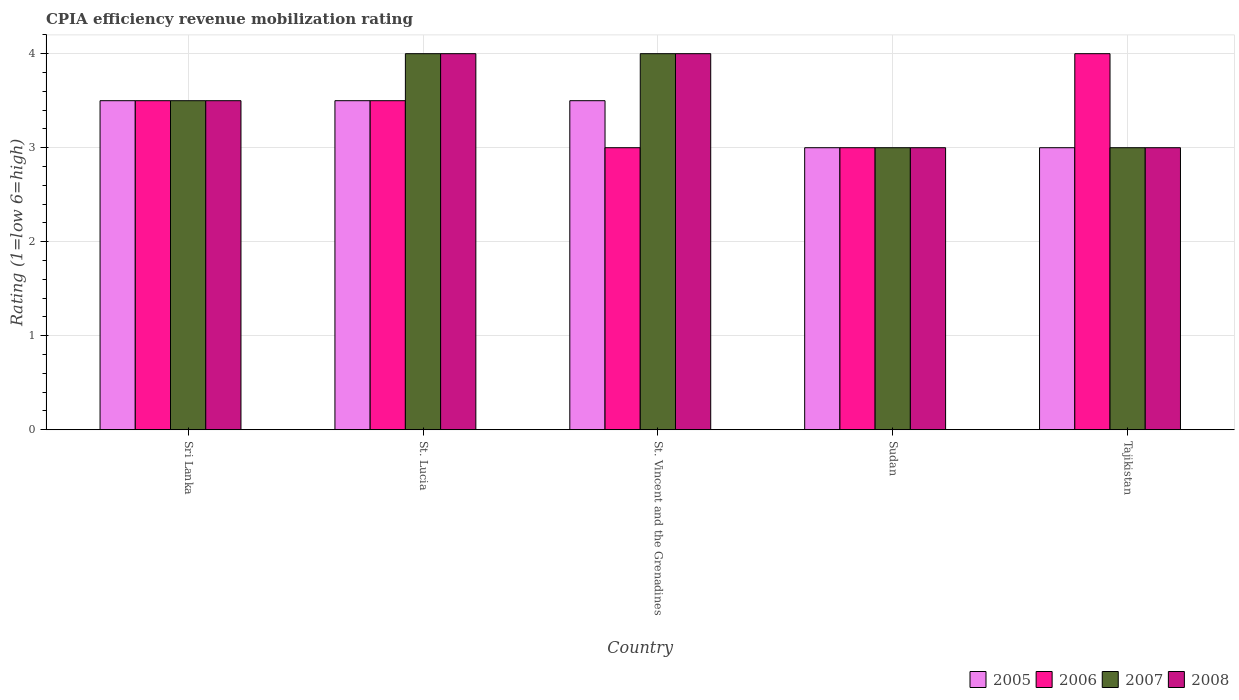How many different coloured bars are there?
Provide a short and direct response. 4. How many groups of bars are there?
Provide a short and direct response. 5. Are the number of bars on each tick of the X-axis equal?
Provide a succinct answer. Yes. How many bars are there on the 1st tick from the left?
Provide a succinct answer. 4. How many bars are there on the 1st tick from the right?
Offer a terse response. 4. What is the label of the 2nd group of bars from the left?
Ensure brevity in your answer.  St. Lucia. Across all countries, what is the maximum CPIA rating in 2006?
Make the answer very short. 4. In which country was the CPIA rating in 2007 maximum?
Your answer should be very brief. St. Lucia. In which country was the CPIA rating in 2007 minimum?
Your answer should be very brief. Sudan. What is the difference between the CPIA rating in 2006 in Sri Lanka and that in St. Vincent and the Grenadines?
Offer a terse response. 0.5. What is the difference between the CPIA rating in 2007 in Sri Lanka and the CPIA rating in 2008 in Sudan?
Keep it short and to the point. 0.5. What is the average CPIA rating in 2007 per country?
Ensure brevity in your answer.  3.5. What is the difference between the CPIA rating of/in 2007 and CPIA rating of/in 2006 in Tajikistan?
Make the answer very short. -1. In how many countries, is the CPIA rating in 2008 greater than 3?
Keep it short and to the point. 3. What is the ratio of the CPIA rating in 2007 in St. Vincent and the Grenadines to that in Sudan?
Your answer should be very brief. 1.33. Is the CPIA rating in 2005 in Sri Lanka less than that in St. Lucia?
Your answer should be compact. No. Is the difference between the CPIA rating in 2007 in St. Lucia and Tajikistan greater than the difference between the CPIA rating in 2006 in St. Lucia and Tajikistan?
Provide a short and direct response. Yes. What is the difference between the highest and the second highest CPIA rating in 2006?
Your answer should be compact. -0.5. What is the difference between the highest and the lowest CPIA rating in 2007?
Give a very brief answer. 1. In how many countries, is the CPIA rating in 2007 greater than the average CPIA rating in 2007 taken over all countries?
Make the answer very short. 2. Is the sum of the CPIA rating in 2005 in Sri Lanka and Sudan greater than the maximum CPIA rating in 2008 across all countries?
Provide a succinct answer. Yes. Is it the case that in every country, the sum of the CPIA rating in 2007 and CPIA rating in 2008 is greater than the sum of CPIA rating in 2005 and CPIA rating in 2006?
Your answer should be compact. No. What does the 3rd bar from the right in St. Vincent and the Grenadines represents?
Give a very brief answer. 2006. Are all the bars in the graph horizontal?
Your response must be concise. No. What is the difference between two consecutive major ticks on the Y-axis?
Ensure brevity in your answer.  1. How are the legend labels stacked?
Offer a very short reply. Horizontal. What is the title of the graph?
Offer a very short reply. CPIA efficiency revenue mobilization rating. What is the label or title of the X-axis?
Ensure brevity in your answer.  Country. What is the label or title of the Y-axis?
Offer a very short reply. Rating (1=low 6=high). What is the Rating (1=low 6=high) in 2005 in Sri Lanka?
Your answer should be compact. 3.5. What is the Rating (1=low 6=high) in 2006 in Sri Lanka?
Your response must be concise. 3.5. What is the Rating (1=low 6=high) in 2007 in Sri Lanka?
Offer a very short reply. 3.5. What is the Rating (1=low 6=high) of 2008 in Sri Lanka?
Make the answer very short. 3.5. What is the Rating (1=low 6=high) of 2005 in St. Lucia?
Your answer should be very brief. 3.5. What is the Rating (1=low 6=high) of 2007 in St. Lucia?
Make the answer very short. 4. What is the Rating (1=low 6=high) of 2005 in St. Vincent and the Grenadines?
Offer a very short reply. 3.5. What is the Rating (1=low 6=high) of 2008 in St. Vincent and the Grenadines?
Your response must be concise. 4. What is the Rating (1=low 6=high) of 2005 in Sudan?
Your answer should be very brief. 3. What is the Rating (1=low 6=high) in 2006 in Sudan?
Ensure brevity in your answer.  3. Across all countries, what is the maximum Rating (1=low 6=high) in 2005?
Provide a succinct answer. 3.5. Across all countries, what is the maximum Rating (1=low 6=high) of 2008?
Provide a short and direct response. 4. Across all countries, what is the minimum Rating (1=low 6=high) in 2005?
Your answer should be compact. 3. Across all countries, what is the minimum Rating (1=low 6=high) of 2008?
Make the answer very short. 3. What is the total Rating (1=low 6=high) in 2006 in the graph?
Offer a terse response. 17. What is the total Rating (1=low 6=high) of 2007 in the graph?
Ensure brevity in your answer.  17.5. What is the total Rating (1=low 6=high) in 2008 in the graph?
Provide a succinct answer. 17.5. What is the difference between the Rating (1=low 6=high) of 2007 in Sri Lanka and that in St. Lucia?
Keep it short and to the point. -0.5. What is the difference between the Rating (1=low 6=high) of 2005 in Sri Lanka and that in St. Vincent and the Grenadines?
Keep it short and to the point. 0. What is the difference between the Rating (1=low 6=high) in 2008 in Sri Lanka and that in St. Vincent and the Grenadines?
Make the answer very short. -0.5. What is the difference between the Rating (1=low 6=high) in 2005 in Sri Lanka and that in Sudan?
Keep it short and to the point. 0.5. What is the difference between the Rating (1=low 6=high) of 2006 in Sri Lanka and that in Sudan?
Your response must be concise. 0.5. What is the difference between the Rating (1=low 6=high) of 2007 in Sri Lanka and that in Sudan?
Provide a succinct answer. 0.5. What is the difference between the Rating (1=low 6=high) in 2008 in Sri Lanka and that in Sudan?
Give a very brief answer. 0.5. What is the difference between the Rating (1=low 6=high) of 2006 in Sri Lanka and that in Tajikistan?
Your response must be concise. -0.5. What is the difference between the Rating (1=low 6=high) of 2007 in Sri Lanka and that in Tajikistan?
Offer a terse response. 0.5. What is the difference between the Rating (1=low 6=high) of 2008 in Sri Lanka and that in Tajikistan?
Make the answer very short. 0.5. What is the difference between the Rating (1=low 6=high) in 2006 in St. Lucia and that in St. Vincent and the Grenadines?
Your answer should be compact. 0.5. What is the difference between the Rating (1=low 6=high) in 2006 in St. Lucia and that in Sudan?
Offer a very short reply. 0.5. What is the difference between the Rating (1=low 6=high) in 2008 in St. Lucia and that in Sudan?
Keep it short and to the point. 1. What is the difference between the Rating (1=low 6=high) of 2005 in St. Vincent and the Grenadines and that in Sudan?
Offer a terse response. 0.5. What is the difference between the Rating (1=low 6=high) in 2006 in St. Vincent and the Grenadines and that in Sudan?
Give a very brief answer. 0. What is the difference between the Rating (1=low 6=high) of 2007 in St. Vincent and the Grenadines and that in Sudan?
Keep it short and to the point. 1. What is the difference between the Rating (1=low 6=high) of 2006 in St. Vincent and the Grenadines and that in Tajikistan?
Offer a terse response. -1. What is the difference between the Rating (1=low 6=high) in 2007 in St. Vincent and the Grenadines and that in Tajikistan?
Provide a succinct answer. 1. What is the difference between the Rating (1=low 6=high) in 2005 in Sudan and that in Tajikistan?
Make the answer very short. 0. What is the difference between the Rating (1=low 6=high) of 2007 in Sudan and that in Tajikistan?
Offer a very short reply. 0. What is the difference between the Rating (1=low 6=high) of 2005 in Sri Lanka and the Rating (1=low 6=high) of 2006 in St. Lucia?
Your answer should be compact. 0. What is the difference between the Rating (1=low 6=high) in 2005 in Sri Lanka and the Rating (1=low 6=high) in 2007 in St. Lucia?
Your answer should be compact. -0.5. What is the difference between the Rating (1=low 6=high) of 2006 in Sri Lanka and the Rating (1=low 6=high) of 2007 in St. Lucia?
Offer a terse response. -0.5. What is the difference between the Rating (1=low 6=high) of 2006 in Sri Lanka and the Rating (1=low 6=high) of 2008 in St. Lucia?
Offer a very short reply. -0.5. What is the difference between the Rating (1=low 6=high) of 2007 in Sri Lanka and the Rating (1=low 6=high) of 2008 in St. Vincent and the Grenadines?
Your answer should be very brief. -0.5. What is the difference between the Rating (1=low 6=high) of 2005 in Sri Lanka and the Rating (1=low 6=high) of 2007 in Sudan?
Offer a very short reply. 0.5. What is the difference between the Rating (1=low 6=high) in 2005 in Sri Lanka and the Rating (1=low 6=high) in 2008 in Sudan?
Offer a very short reply. 0.5. What is the difference between the Rating (1=low 6=high) in 2006 in Sri Lanka and the Rating (1=low 6=high) in 2007 in Sudan?
Your answer should be very brief. 0.5. What is the difference between the Rating (1=low 6=high) in 2005 in St. Lucia and the Rating (1=low 6=high) in 2006 in St. Vincent and the Grenadines?
Ensure brevity in your answer.  0.5. What is the difference between the Rating (1=low 6=high) in 2005 in St. Lucia and the Rating (1=low 6=high) in 2007 in St. Vincent and the Grenadines?
Offer a terse response. -0.5. What is the difference between the Rating (1=low 6=high) in 2006 in St. Lucia and the Rating (1=low 6=high) in 2007 in St. Vincent and the Grenadines?
Make the answer very short. -0.5. What is the difference between the Rating (1=low 6=high) of 2006 in St. Lucia and the Rating (1=low 6=high) of 2007 in Sudan?
Your answer should be very brief. 0.5. What is the difference between the Rating (1=low 6=high) of 2005 in St. Lucia and the Rating (1=low 6=high) of 2006 in Tajikistan?
Your response must be concise. -0.5. What is the difference between the Rating (1=low 6=high) in 2007 in St. Lucia and the Rating (1=low 6=high) in 2008 in Tajikistan?
Keep it short and to the point. 1. What is the difference between the Rating (1=low 6=high) in 2005 in St. Vincent and the Grenadines and the Rating (1=low 6=high) in 2006 in Sudan?
Provide a short and direct response. 0.5. What is the difference between the Rating (1=low 6=high) in 2005 in St. Vincent and the Grenadines and the Rating (1=low 6=high) in 2008 in Sudan?
Provide a succinct answer. 0.5. What is the difference between the Rating (1=low 6=high) in 2006 in St. Vincent and the Grenadines and the Rating (1=low 6=high) in 2008 in Sudan?
Provide a succinct answer. 0. What is the difference between the Rating (1=low 6=high) of 2007 in St. Vincent and the Grenadines and the Rating (1=low 6=high) of 2008 in Sudan?
Make the answer very short. 1. What is the difference between the Rating (1=low 6=high) of 2005 in St. Vincent and the Grenadines and the Rating (1=low 6=high) of 2006 in Tajikistan?
Ensure brevity in your answer.  -0.5. What is the difference between the Rating (1=low 6=high) of 2006 in St. Vincent and the Grenadines and the Rating (1=low 6=high) of 2008 in Tajikistan?
Provide a short and direct response. 0. What is the difference between the Rating (1=low 6=high) of 2007 in St. Vincent and the Grenadines and the Rating (1=low 6=high) of 2008 in Tajikistan?
Keep it short and to the point. 1. What is the difference between the Rating (1=low 6=high) in 2005 in Sudan and the Rating (1=low 6=high) in 2007 in Tajikistan?
Provide a short and direct response. 0. What is the difference between the Rating (1=low 6=high) of 2006 in Sudan and the Rating (1=low 6=high) of 2008 in Tajikistan?
Keep it short and to the point. 0. What is the average Rating (1=low 6=high) in 2005 per country?
Give a very brief answer. 3.3. What is the average Rating (1=low 6=high) of 2006 per country?
Keep it short and to the point. 3.4. What is the difference between the Rating (1=low 6=high) of 2005 and Rating (1=low 6=high) of 2006 in Sri Lanka?
Provide a short and direct response. 0. What is the difference between the Rating (1=low 6=high) in 2005 and Rating (1=low 6=high) in 2007 in Sri Lanka?
Keep it short and to the point. 0. What is the difference between the Rating (1=low 6=high) in 2006 and Rating (1=low 6=high) in 2007 in Sri Lanka?
Ensure brevity in your answer.  0. What is the difference between the Rating (1=low 6=high) of 2006 and Rating (1=low 6=high) of 2008 in Sri Lanka?
Offer a terse response. 0. What is the difference between the Rating (1=low 6=high) of 2007 and Rating (1=low 6=high) of 2008 in Sri Lanka?
Your answer should be very brief. 0. What is the difference between the Rating (1=low 6=high) in 2005 and Rating (1=low 6=high) in 2006 in St. Lucia?
Make the answer very short. 0. What is the difference between the Rating (1=low 6=high) of 2005 and Rating (1=low 6=high) of 2007 in St. Lucia?
Your answer should be compact. -0.5. What is the difference between the Rating (1=low 6=high) of 2005 and Rating (1=low 6=high) of 2008 in St. Lucia?
Provide a succinct answer. -0.5. What is the difference between the Rating (1=low 6=high) of 2007 and Rating (1=low 6=high) of 2008 in St. Lucia?
Offer a very short reply. 0. What is the difference between the Rating (1=low 6=high) in 2005 and Rating (1=low 6=high) in 2007 in St. Vincent and the Grenadines?
Your answer should be compact. -0.5. What is the difference between the Rating (1=low 6=high) of 2006 and Rating (1=low 6=high) of 2007 in St. Vincent and the Grenadines?
Make the answer very short. -1. What is the difference between the Rating (1=low 6=high) of 2006 and Rating (1=low 6=high) of 2008 in St. Vincent and the Grenadines?
Provide a succinct answer. -1. What is the difference between the Rating (1=low 6=high) of 2007 and Rating (1=low 6=high) of 2008 in St. Vincent and the Grenadines?
Your response must be concise. 0. What is the difference between the Rating (1=low 6=high) in 2005 and Rating (1=low 6=high) in 2008 in Tajikistan?
Your response must be concise. 0. What is the difference between the Rating (1=low 6=high) in 2006 and Rating (1=low 6=high) in 2007 in Tajikistan?
Offer a terse response. 1. What is the difference between the Rating (1=low 6=high) in 2007 and Rating (1=low 6=high) in 2008 in Tajikistan?
Give a very brief answer. 0. What is the ratio of the Rating (1=low 6=high) in 2005 in Sri Lanka to that in St. Lucia?
Keep it short and to the point. 1. What is the ratio of the Rating (1=low 6=high) in 2007 in Sri Lanka to that in St. Lucia?
Make the answer very short. 0.88. What is the ratio of the Rating (1=low 6=high) of 2005 in Sri Lanka to that in St. Vincent and the Grenadines?
Offer a very short reply. 1. What is the ratio of the Rating (1=low 6=high) of 2006 in Sri Lanka to that in St. Vincent and the Grenadines?
Your answer should be compact. 1.17. What is the ratio of the Rating (1=low 6=high) in 2005 in Sri Lanka to that in Sudan?
Provide a succinct answer. 1.17. What is the ratio of the Rating (1=low 6=high) in 2006 in Sri Lanka to that in Sudan?
Offer a very short reply. 1.17. What is the ratio of the Rating (1=low 6=high) of 2007 in Sri Lanka to that in Sudan?
Offer a terse response. 1.17. What is the ratio of the Rating (1=low 6=high) in 2008 in St. Lucia to that in St. Vincent and the Grenadines?
Offer a very short reply. 1. What is the ratio of the Rating (1=low 6=high) of 2006 in St. Lucia to that in Sudan?
Make the answer very short. 1.17. What is the ratio of the Rating (1=low 6=high) in 2008 in St. Lucia to that in Sudan?
Provide a succinct answer. 1.33. What is the ratio of the Rating (1=low 6=high) in 2006 in St. Lucia to that in Tajikistan?
Give a very brief answer. 0.88. What is the ratio of the Rating (1=low 6=high) of 2005 in St. Vincent and the Grenadines to that in Sudan?
Your answer should be compact. 1.17. What is the ratio of the Rating (1=low 6=high) of 2006 in St. Vincent and the Grenadines to that in Sudan?
Your answer should be very brief. 1. What is the ratio of the Rating (1=low 6=high) of 2007 in St. Vincent and the Grenadines to that in Sudan?
Offer a terse response. 1.33. What is the ratio of the Rating (1=low 6=high) of 2006 in Sudan to that in Tajikistan?
Offer a terse response. 0.75. What is the ratio of the Rating (1=low 6=high) of 2007 in Sudan to that in Tajikistan?
Your answer should be compact. 1. What is the ratio of the Rating (1=low 6=high) of 2008 in Sudan to that in Tajikistan?
Give a very brief answer. 1. What is the difference between the highest and the second highest Rating (1=low 6=high) of 2005?
Keep it short and to the point. 0. What is the difference between the highest and the second highest Rating (1=low 6=high) of 2006?
Your answer should be compact. 0.5. What is the difference between the highest and the second highest Rating (1=low 6=high) of 2007?
Make the answer very short. 0. What is the difference between the highest and the lowest Rating (1=low 6=high) in 2005?
Offer a very short reply. 0.5. What is the difference between the highest and the lowest Rating (1=low 6=high) in 2006?
Give a very brief answer. 1. What is the difference between the highest and the lowest Rating (1=low 6=high) in 2007?
Ensure brevity in your answer.  1. 